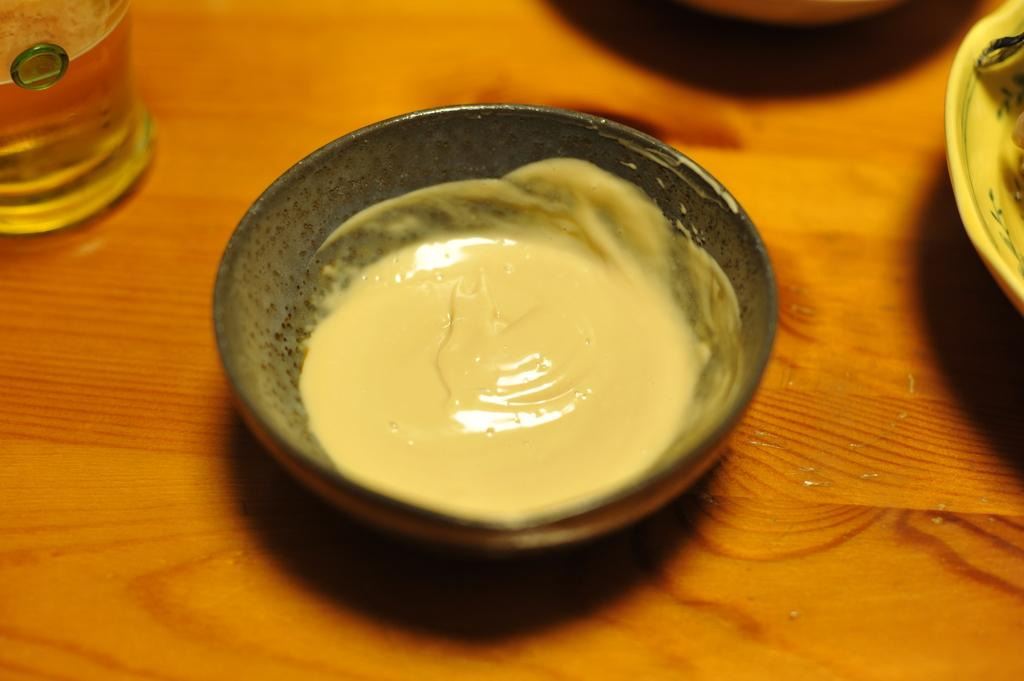What is in the bowl that is visible in the image? There is a bowl with cream in the image. What else is visible in the image besides the bowl of cream? There is a glass with a drink and a plate with food in the image. What might be used to hold the bowl, glass, and plate in the image? There is a wooden object that resembles a table in the image. What type of pig can be seen sitting on the table in the image? There is no pig present in the image; it features a bowl with cream, a glass with a drink, a plate with food, and a wooden object that resembles a table. What kind of sponge is used to clean the table in the image? There is no sponge visible in the image, and it is not possible to determine what type of sponge might be used to clean the table. 